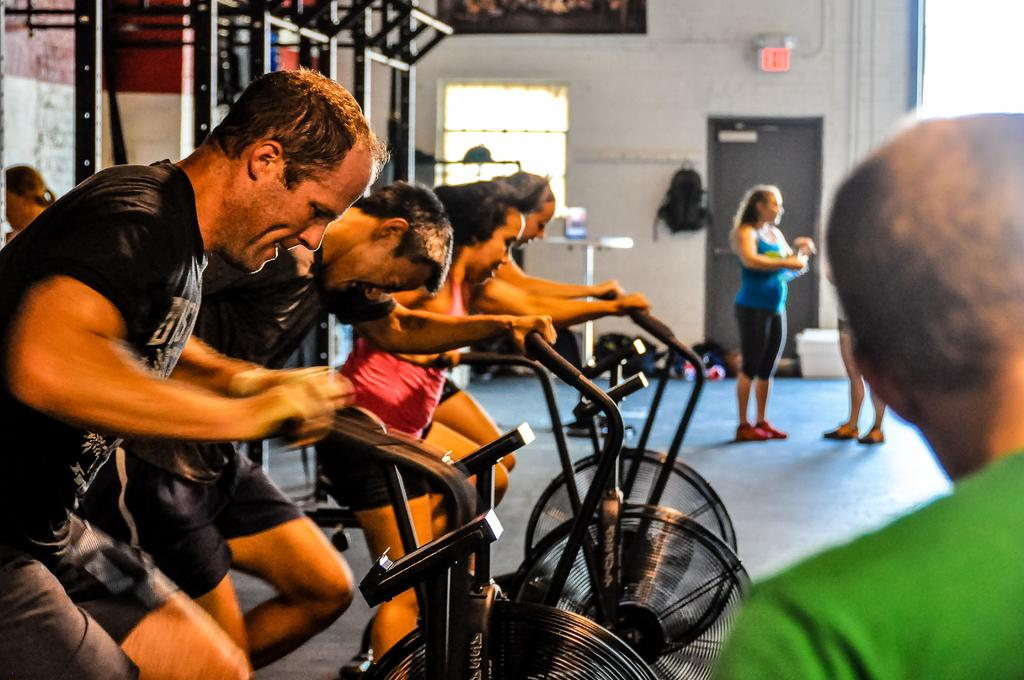What activity are the people in the gym engaged in? The people in the gym are cycling. What other types of equipment can be seen in the gym? There are other gym equipment in the image. What is the position of the people who are not cycling in the gym? There are people standing on the floor in the gym. Can you see your uncle wearing a veil while cycling in the gym? There is no uncle or veil present in the image; it only shows people cycling and other gym equipment. 